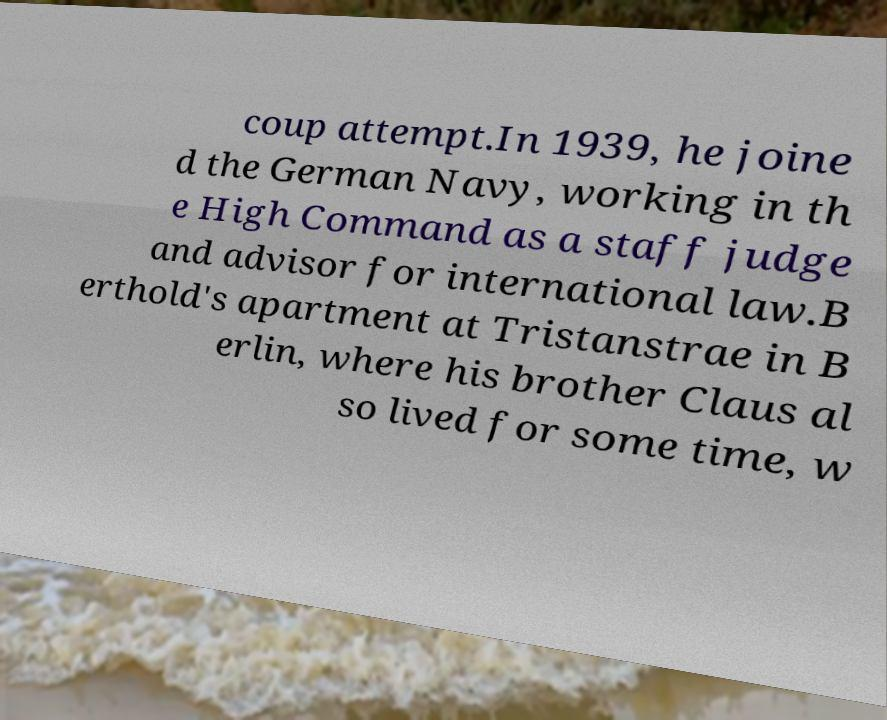Can you read and provide the text displayed in the image?This photo seems to have some interesting text. Can you extract and type it out for me? coup attempt.In 1939, he joine d the German Navy, working in th e High Command as a staff judge and advisor for international law.B erthold's apartment at Tristanstrae in B erlin, where his brother Claus al so lived for some time, w 